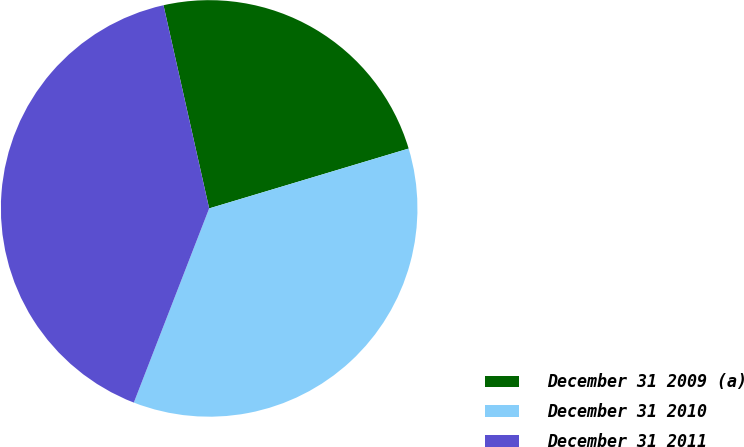Convert chart. <chart><loc_0><loc_0><loc_500><loc_500><pie_chart><fcel>December 31 2009 (a)<fcel>December 31 2010<fcel>December 31 2011<nl><fcel>23.88%<fcel>35.53%<fcel>40.59%<nl></chart> 